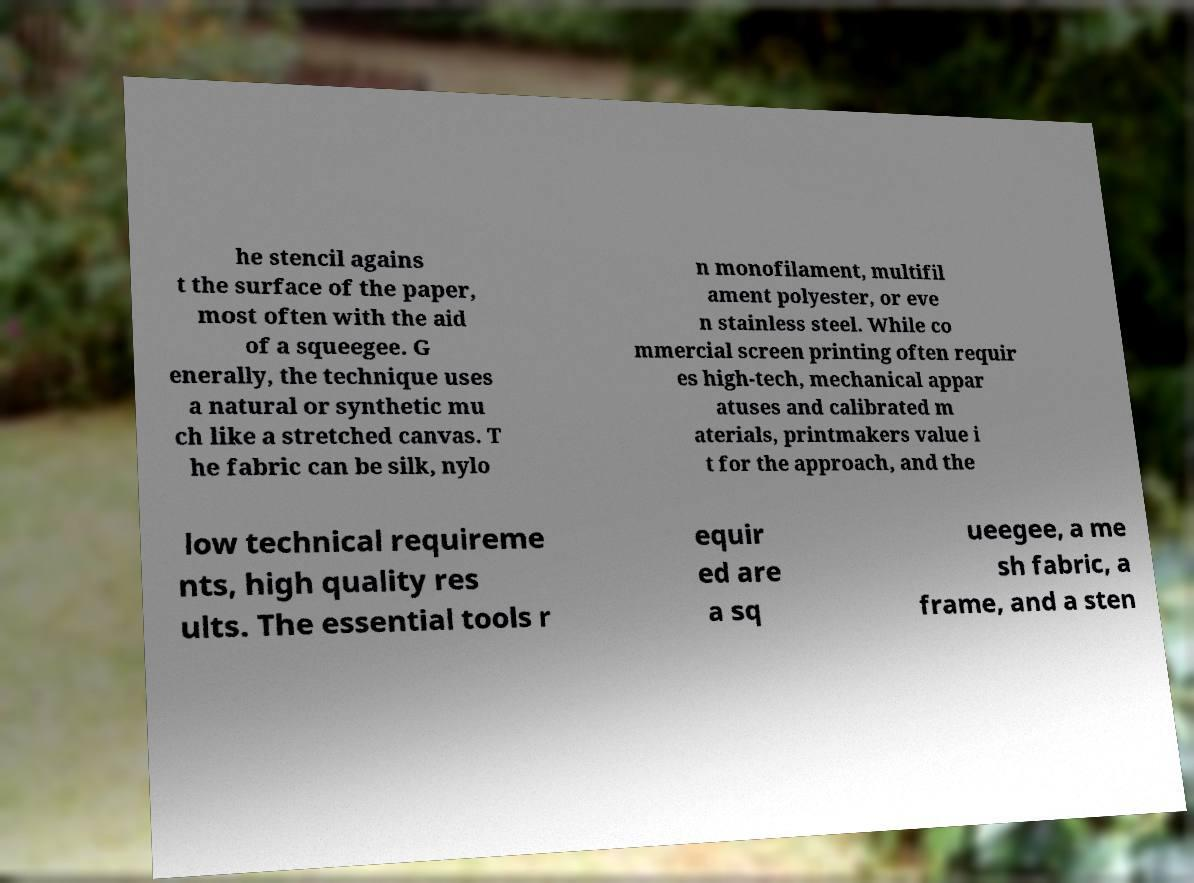Could you extract and type out the text from this image? he stencil agains t the surface of the paper, most often with the aid of a squeegee. G enerally, the technique uses a natural or synthetic mu ch like a stretched canvas. T he fabric can be silk, nylo n monofilament, multifil ament polyester, or eve n stainless steel. While co mmercial screen printing often requir es high-tech, mechanical appar atuses and calibrated m aterials, printmakers value i t for the approach, and the low technical requireme nts, high quality res ults. The essential tools r equir ed are a sq ueegee, a me sh fabric, a frame, and a sten 